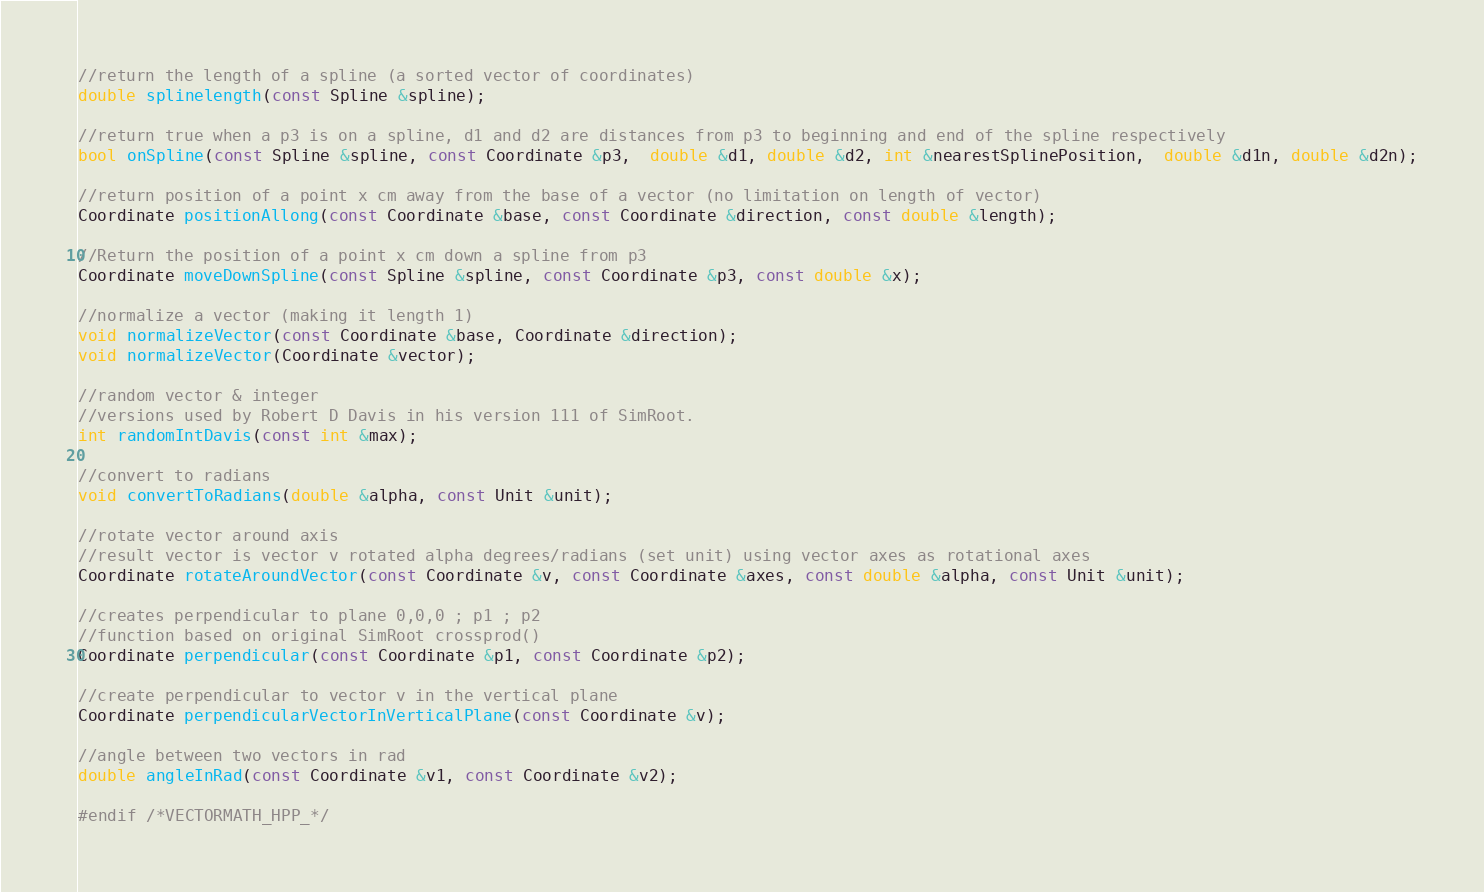Convert code to text. <code><loc_0><loc_0><loc_500><loc_500><_C++_>
//return the length of a spline (a sorted vector of coordinates)
double splinelength(const Spline &spline);

//return true when a p3 is on a spline, d1 and d2 are distances from p3 to beginning and end of the spline respectively
bool onSpline(const Spline &spline, const Coordinate &p3,  double &d1, double &d2, int &nearestSplinePosition,  double &d1n, double &d2n);

//return position of a point x cm away from the base of a vector (no limitation on length of vector)
Coordinate positionAllong(const Coordinate &base, const Coordinate &direction, const double &length);

//Return the position of a point x cm down a spline from p3
Coordinate moveDownSpline(const Spline &spline, const Coordinate &p3, const double &x);

//normalize a vector (making it length 1)
void normalizeVector(const Coordinate &base, Coordinate &direction);
void normalizeVector(Coordinate &vector);

//random vector & integer
//versions used by Robert D Davis in his version 111 of SimRoot.
int randomIntDavis(const int &max);

//convert to radians
void convertToRadians(double &alpha, const Unit &unit);

//rotate vector around axis
//result vector is vector v rotated alpha degrees/radians (set unit) using vector axes as rotational axes
Coordinate rotateAroundVector(const Coordinate &v, const Coordinate &axes, const double &alpha, const Unit &unit);

//creates perpendicular to plane 0,0,0 ; p1 ; p2
//function based on original SimRoot crossprod()
Coordinate perpendicular(const Coordinate &p1, const Coordinate &p2);

//create perpendicular to vector v in the vertical plane
Coordinate perpendicularVectorInVerticalPlane(const Coordinate &v);

//angle between two vectors in rad
double angleInRad(const Coordinate &v1, const Coordinate &v2);

#endif /*VECTORMATH_HPP_*/
</code> 